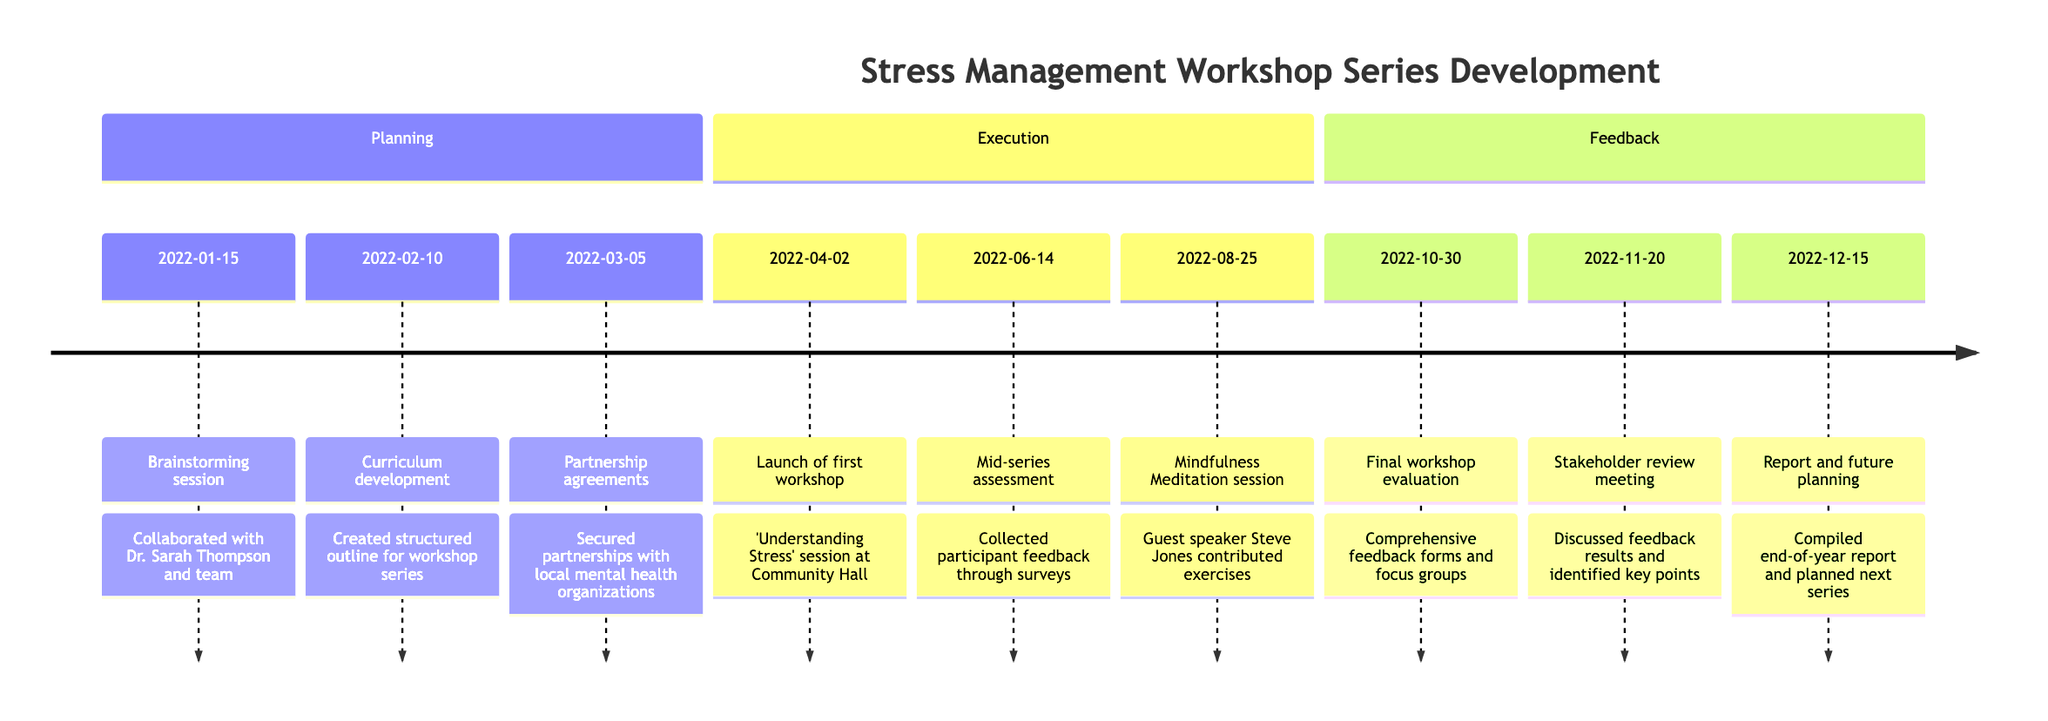What is the date of the first workshop session? The question asks for a specific date related to a particular activity in the timeline. By looking into the Execution section of the timeline, we find that the first workshop session was launched on April 2, 2022.
Answer: April 2, 2022 How many stages are there in the timeline? The timeline presents information organized into distinct sections. By counting the sections, we find three stages: Planning, Execution, and Feedback. This confirms that there are a total of three stages.
Answer: 3 What activity took place on February 10, 2022? This question seeks a specific activity associated with a given date in the timeline. By examining the Planning section, we see that on February 10, 2022, the activity was "Curriculum development."
Answer: Curriculum development Which workshop was conducted by a guest speaker? The inquiry focuses on identifying an activity that involved an external contributor. In the Execution section, it is stated that a session on "Mindfulness Meditation" featured guest speaker, Yoga instructor Steve Jones.
Answer: Mindfulness Meditation What was discussed in the review meeting on November 20, 2022? This question requires understanding the purpose of the review meeting by referring to the Feedback section. By examining the details, we find that the meeting involved discussing feedback results and identifying key successes and improvements needed for future series.
Answer: Feedback results and key points What stage follows the Execution stage in the timeline? The inquiry focuses on the sequential arrangement of the stages in the timeline. After analyzing the order of sections, we find that the stage that follows Execution is Feedback.
Answer: Feedback How many activities were carried out during the Feedback stage? This requires counting the number of activities listed within the Feedback section of the diagram. There are three distinct activities mentioned in this stage, which are final workshop evaluation, stakeholder review meeting, and report and future planning.
Answer: 3 What was the topic of the first workshop session? The question is focused on identifying the subject matter of a specific activity within the Execution section. According to the timeline, the first workshop session was about "Understanding Stress."
Answer: Understanding Stress Which expert collaborated during the brainstorming session? The inquiry looks for a specific collaborator mentioned in the Planning stage. By checking the details of the activity on January 15, 2022, we see that Dr. Sarah Thompson and her team were involved.
Answer: Dr. Sarah Thompson 